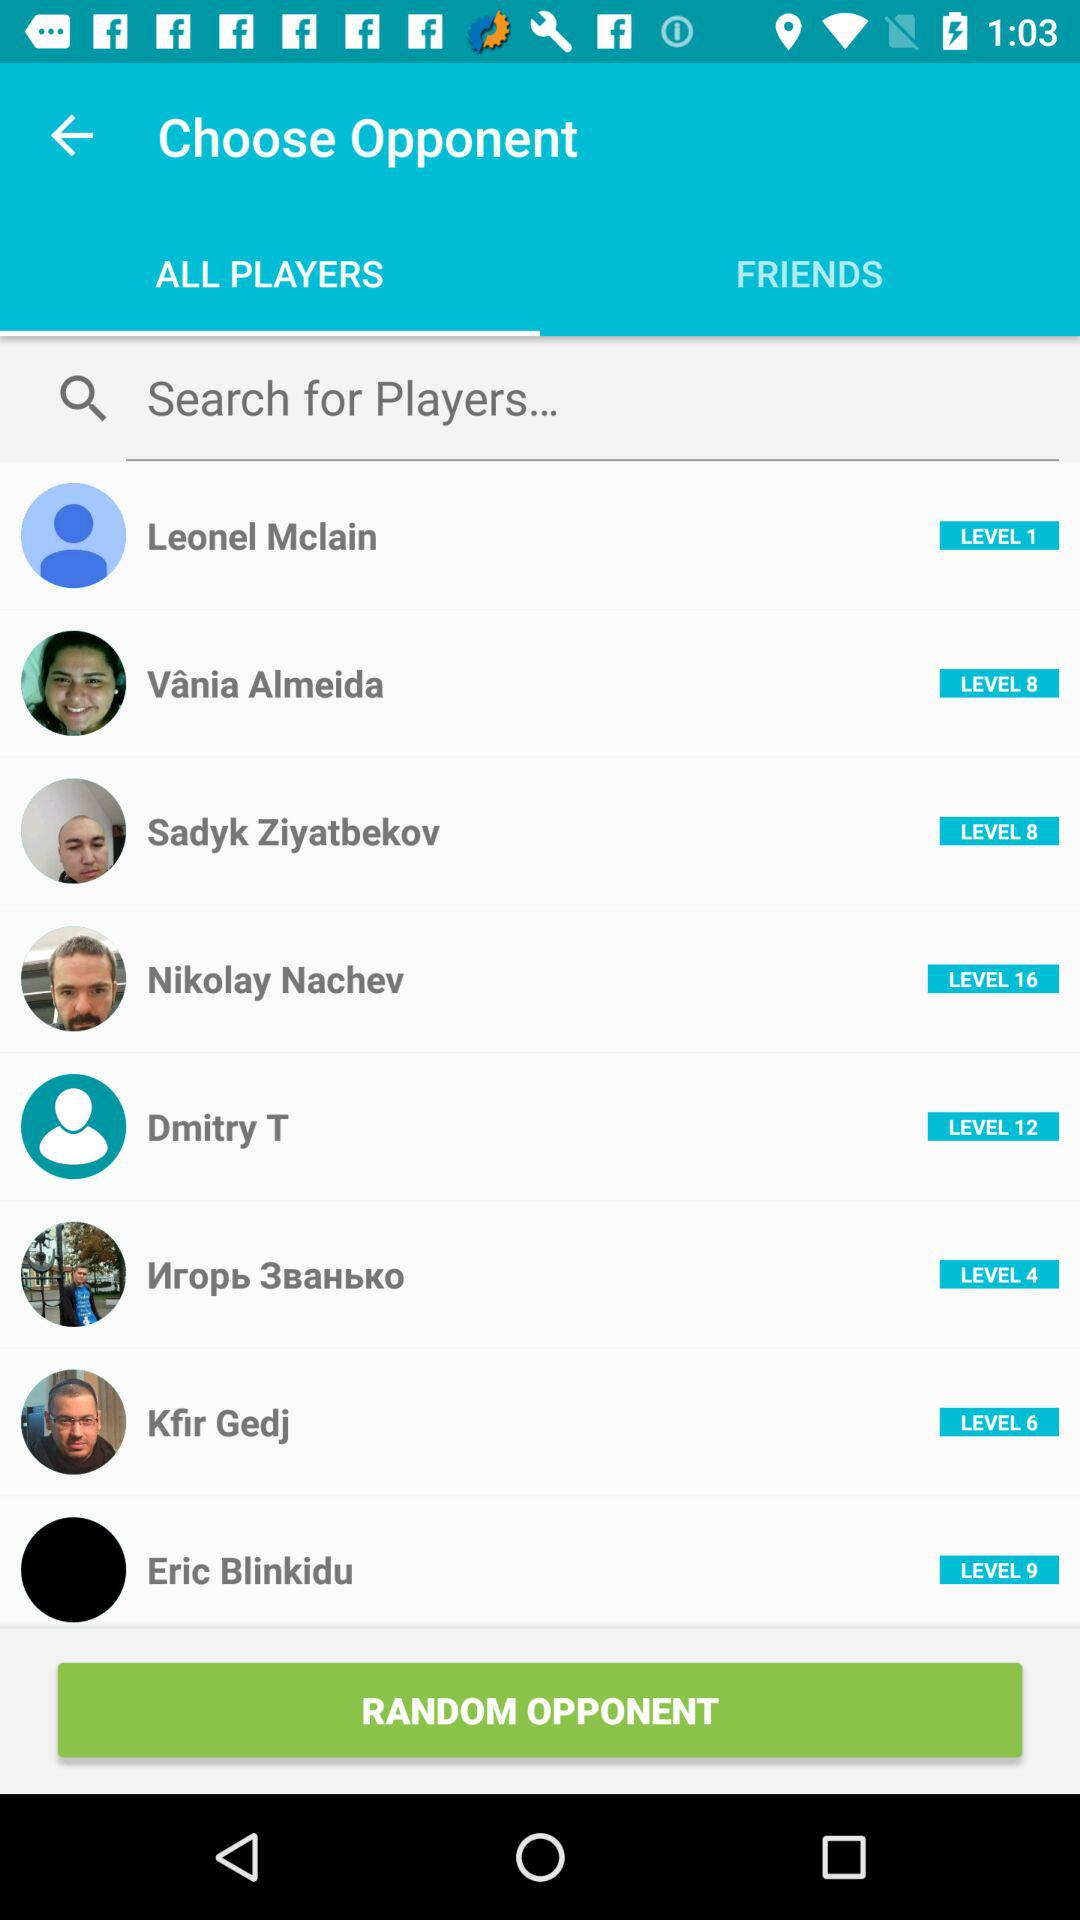What is the name of the player who is at level 9? The name of the player is "Eric Blinkidu". 